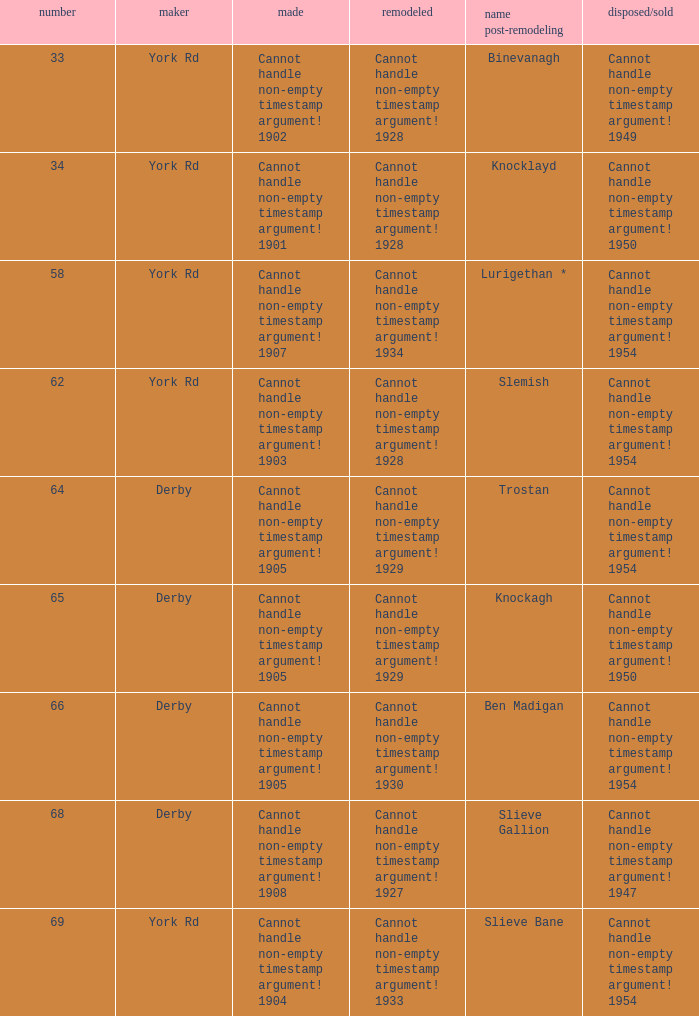Which Scrapped/Sold has a Name as rebuilt of trostan? Cannot handle non-empty timestamp argument! 1954. 